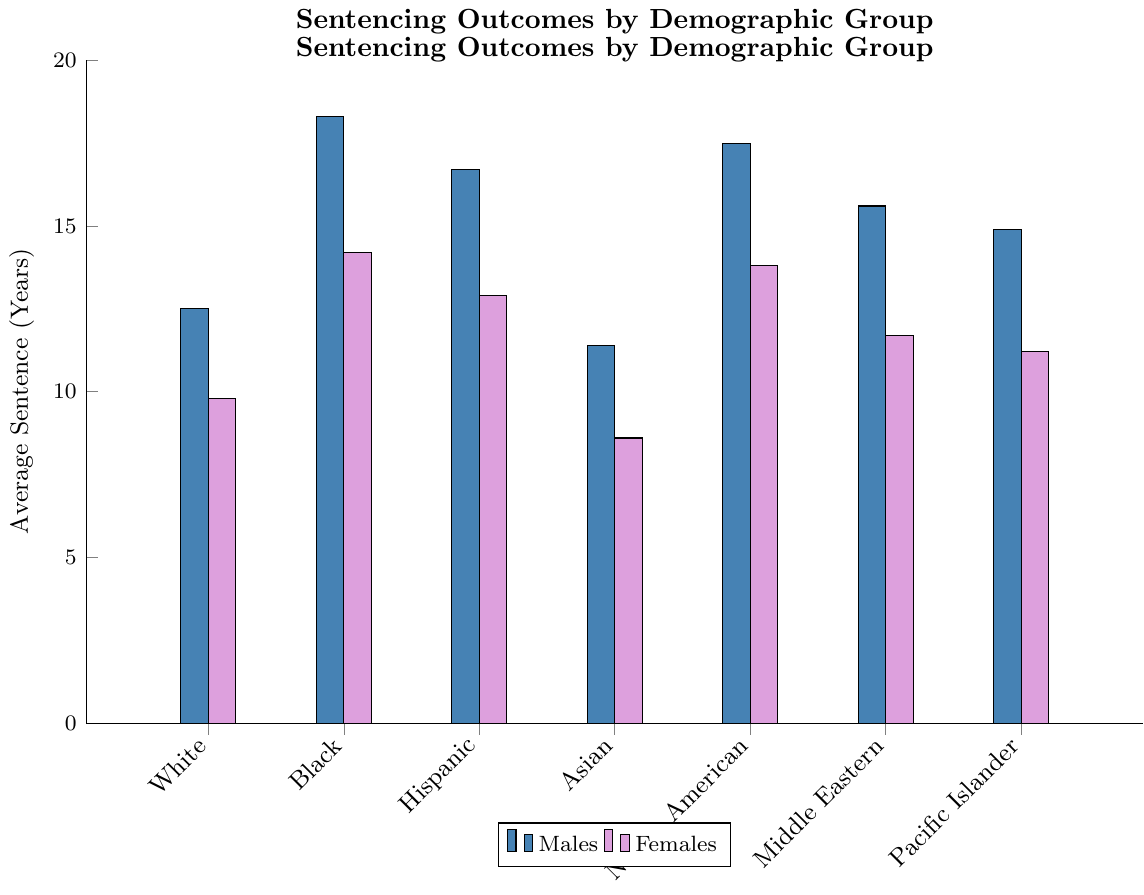Which demographic group has the longest average sentence for males? Look at the height of the bars representing males in each demographic group. The tallest bar for males represents Black males with an average sentence of 18.3 years.
Answer: Black males Which demographic group has the shortest average sentence for females? Look at the height of the bars representing females in each demographic group. The shortest bar for females represents Asian females with an average sentence of 8.6 years.
Answer: Asian females How much longer is the average sentence for Black males compared to White males? Find the average sentence for Black males (18.3 years) and subtract the average sentence for White males (12.5 years). The calculation is 18.3 - 12.5.
Answer: 5.8 years What is the average sentence difference between males and females in the Native American group? Find the average sentence for Native American males (17.5 years) and females (13.8 years). Then, subtract the female sentence from the male sentence: 17.5 - 13.8.
Answer: 3.7 years Which demographic group has a greater average sentence: Hispanic males or Middle Eastern males? Compare the average sentence for Hispanic males (16.7 years) and Middle Eastern males (15.6 years). Hispanic males have a greater average sentence.
Answer: Hispanic males Between Asian females and Pacific Islander females, who has a longer average sentence? Compare the average sentence for Asian females (8.6 years) and Pacific Islander females (11.2 years). Pacific Islander females have a longer average sentence.
Answer: Pacific Islander females What is the combined sentence length for White females and Hispanic females? Add the average sentence for White females (9.8 years) to the average sentence for Hispanic females (12.9 years). The calculation is 9.8 + 12.9.
Answer: 22.7 years What is the difference in average sentencing between Middle Eastern males and females? Find the average sentence for Middle Eastern males (15.6 years) and females (11.7 years). Then, subtract the female sentence from the male sentence: 15.6 - 11.7.
Answer: 3.9 years Which two demographic groups have the closest average sentence for males? Compare the average sentence for males across all demographic groups. Middle Eastern males (15.6 years) and Hispanic males (16.7 years) have values closest to each other.
Answer: Middle Eastern males and Hispanic males Is the average sentence for Pacific Islander females greater or less than the average sentence for Asian males? Compare the average sentence for Pacific Islander females (11.2 years) and Asian males (11.4 years). Pacific Islander females have a slightly lesser average sentence.
Answer: Less 